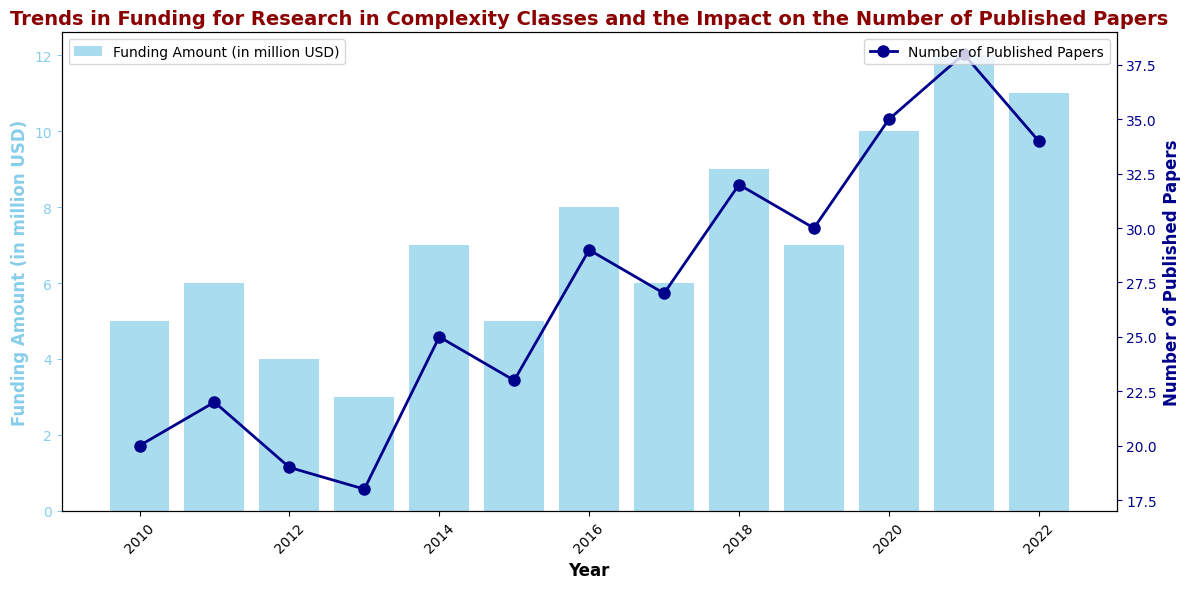What's the trend in the funding amount from 2010 to 2022? Observing the bar chart, the funding amount generally increases from 2010 ($5 million) until 2022 ($11 million), with some fluctuations in the middle years. For example, it decreases slightly in 2012 and 2013 but shows a noticeable increase overall.
Answer: Increasing trend with fluctuations Which year had the highest number of published papers? The scatter points representing the number of published papers reach the highest in 2021 with a count of 38 papers.
Answer: 2021 How does the number of published papers in 2015 compare to 2020? In 2015, there were 23 published papers, while in 2020, there were 35 published papers. Comparing these, 2020 had 12 more published papers than 2015.
Answer: 2020 had 12 more papers What's the sum of the funding amounts in 2012 and 2019? The funding amount in 2012 was $4 million and in 2019 was $7 million. Adding these amounts together gives $4 million + $7 million = $11 million.
Answer: $11 million In which year did the funding amount first reach at least $10 million? The bar chart shows the funding amount reaching $10 million in the year 2020 for the first time.
Answer: 2020 Between which consecutive years did the number of published papers increase by the largest amount? Observing the scatter plot, the largest increase in the number of published papers between consecutive years is from 2019 to 2020, where it rises from 30 to 35 papers, an increase of 5 papers.
Answer: 2019 to 2020 What is the average funding amount over the entire period from 2010 to 2022? Adding the funding amounts for all years and dividing by the number of years: (5 + 6 + 4 + 3 + 7 + 5 + 8 + 6 + 9 + 7 + 10 + 12 + 11) / 13. This equals 93 / 13 ≈ 7.15 million USD.
Answer: Approximately 7.15 million USD In which years were there a decline in both funding and the number of published papers compared to the previous year? Comparing year-to-year data: funding fell in 2013 from 2012, and the published papers also fell in 2013 compared to 2012. Similarly, funding fell in 2022 from 2021, and the published papers also dropped in 2022 from 2021.
Answer: 2013, 2022 How many years saw both increasing funding amounts and an increasing number of published papers compared to the previous year? Check each year, counting those with increases in both metrics compared to the previous year: 2011, 2014, 2016, 2018, 2020, 2021. That totals 6 years.
Answer: 6 years 